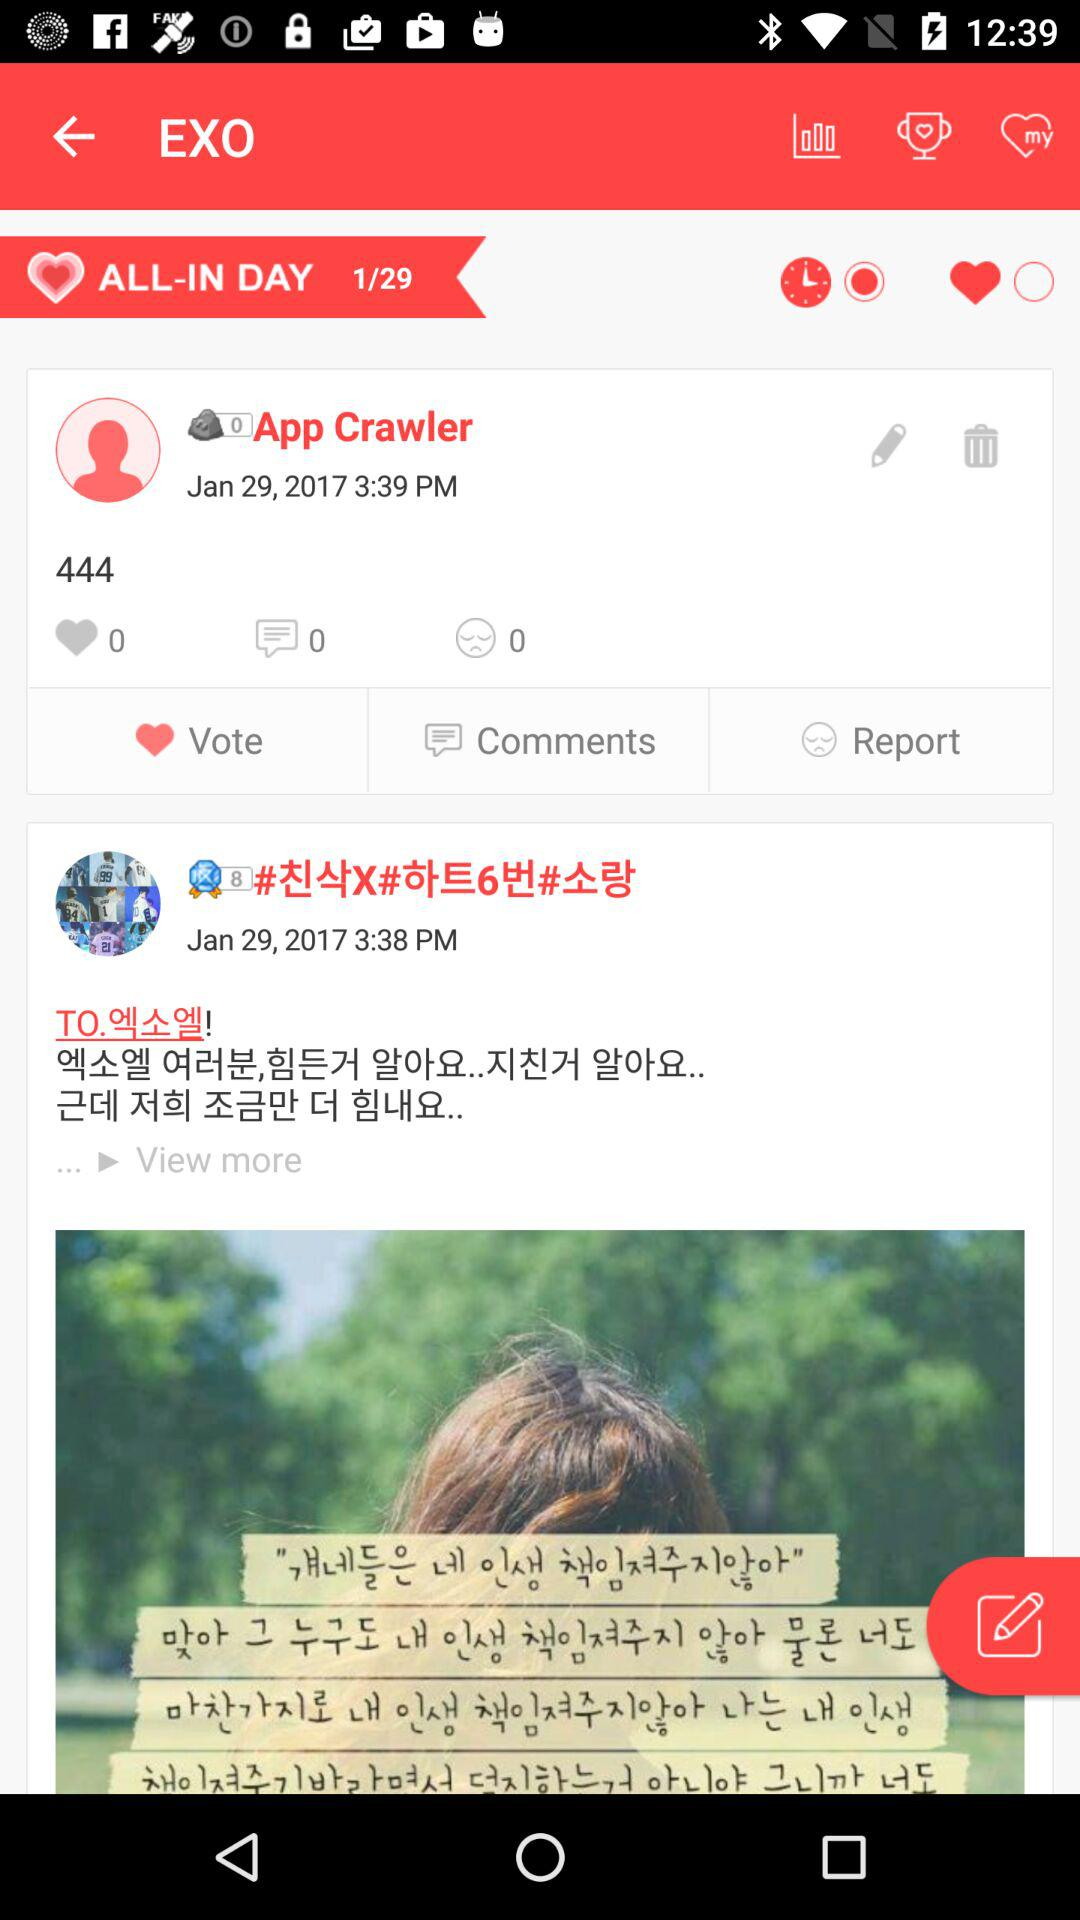What is the application name?
When the provided information is insufficient, respond with <no answer>. <no answer> 